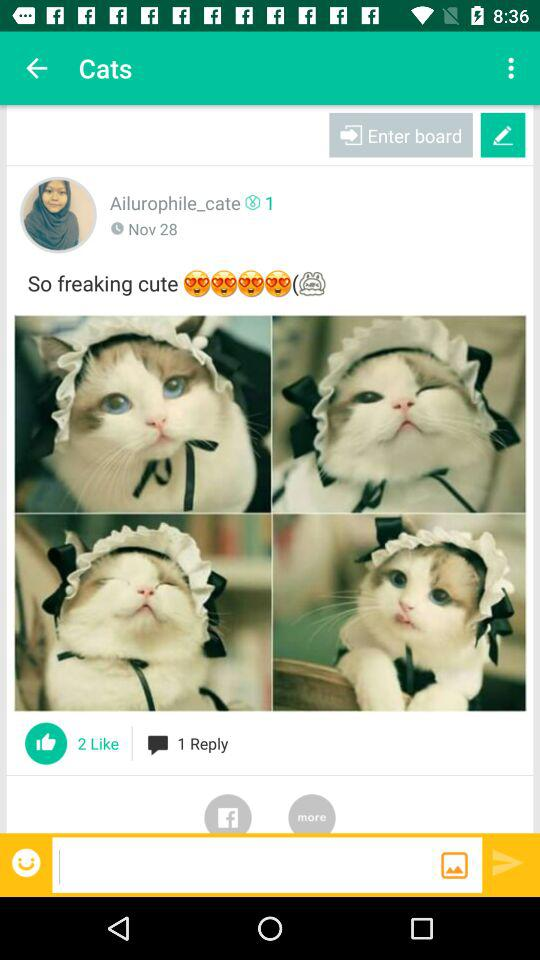How many more likes does the post have than replies?
Answer the question using a single word or phrase. 1 